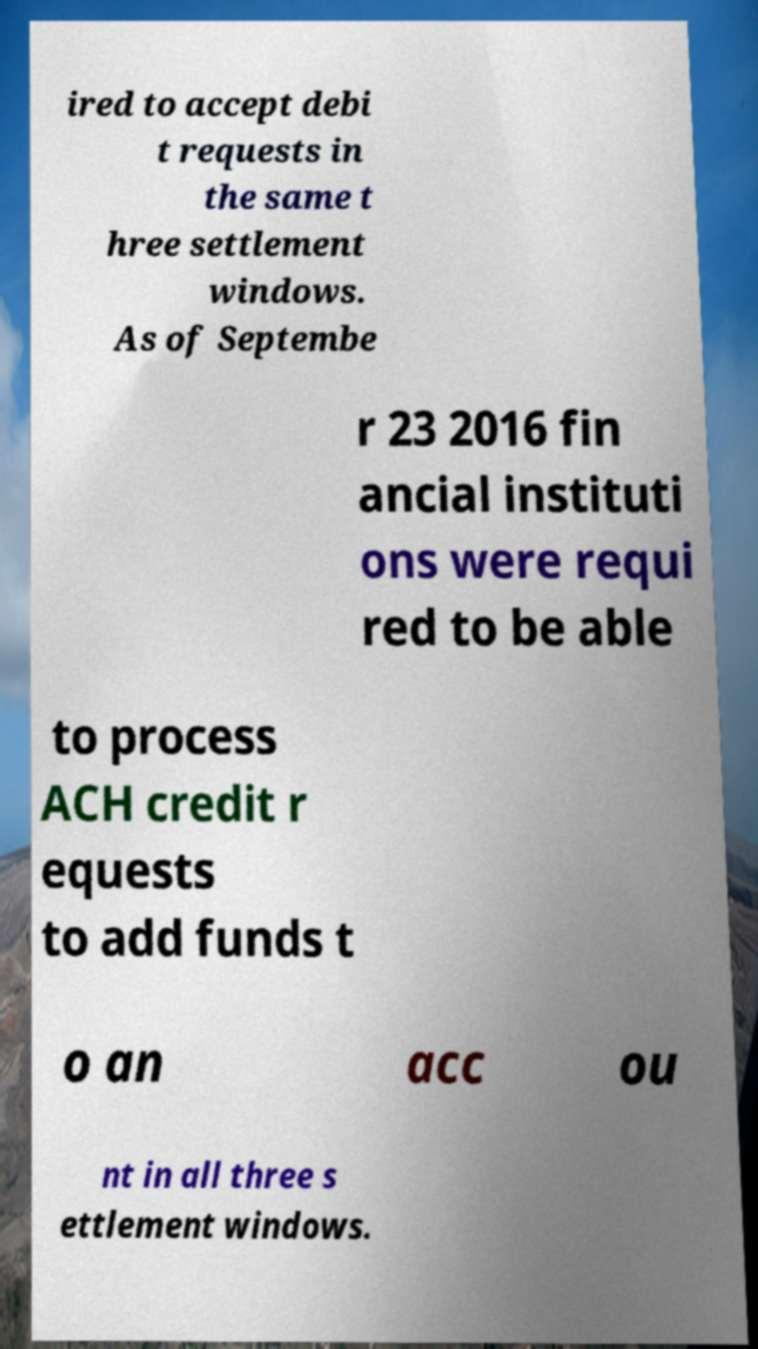Please identify and transcribe the text found in this image. ired to accept debi t requests in the same t hree settlement windows. As of Septembe r 23 2016 fin ancial instituti ons were requi red to be able to process ACH credit r equests to add funds t o an acc ou nt in all three s ettlement windows. 